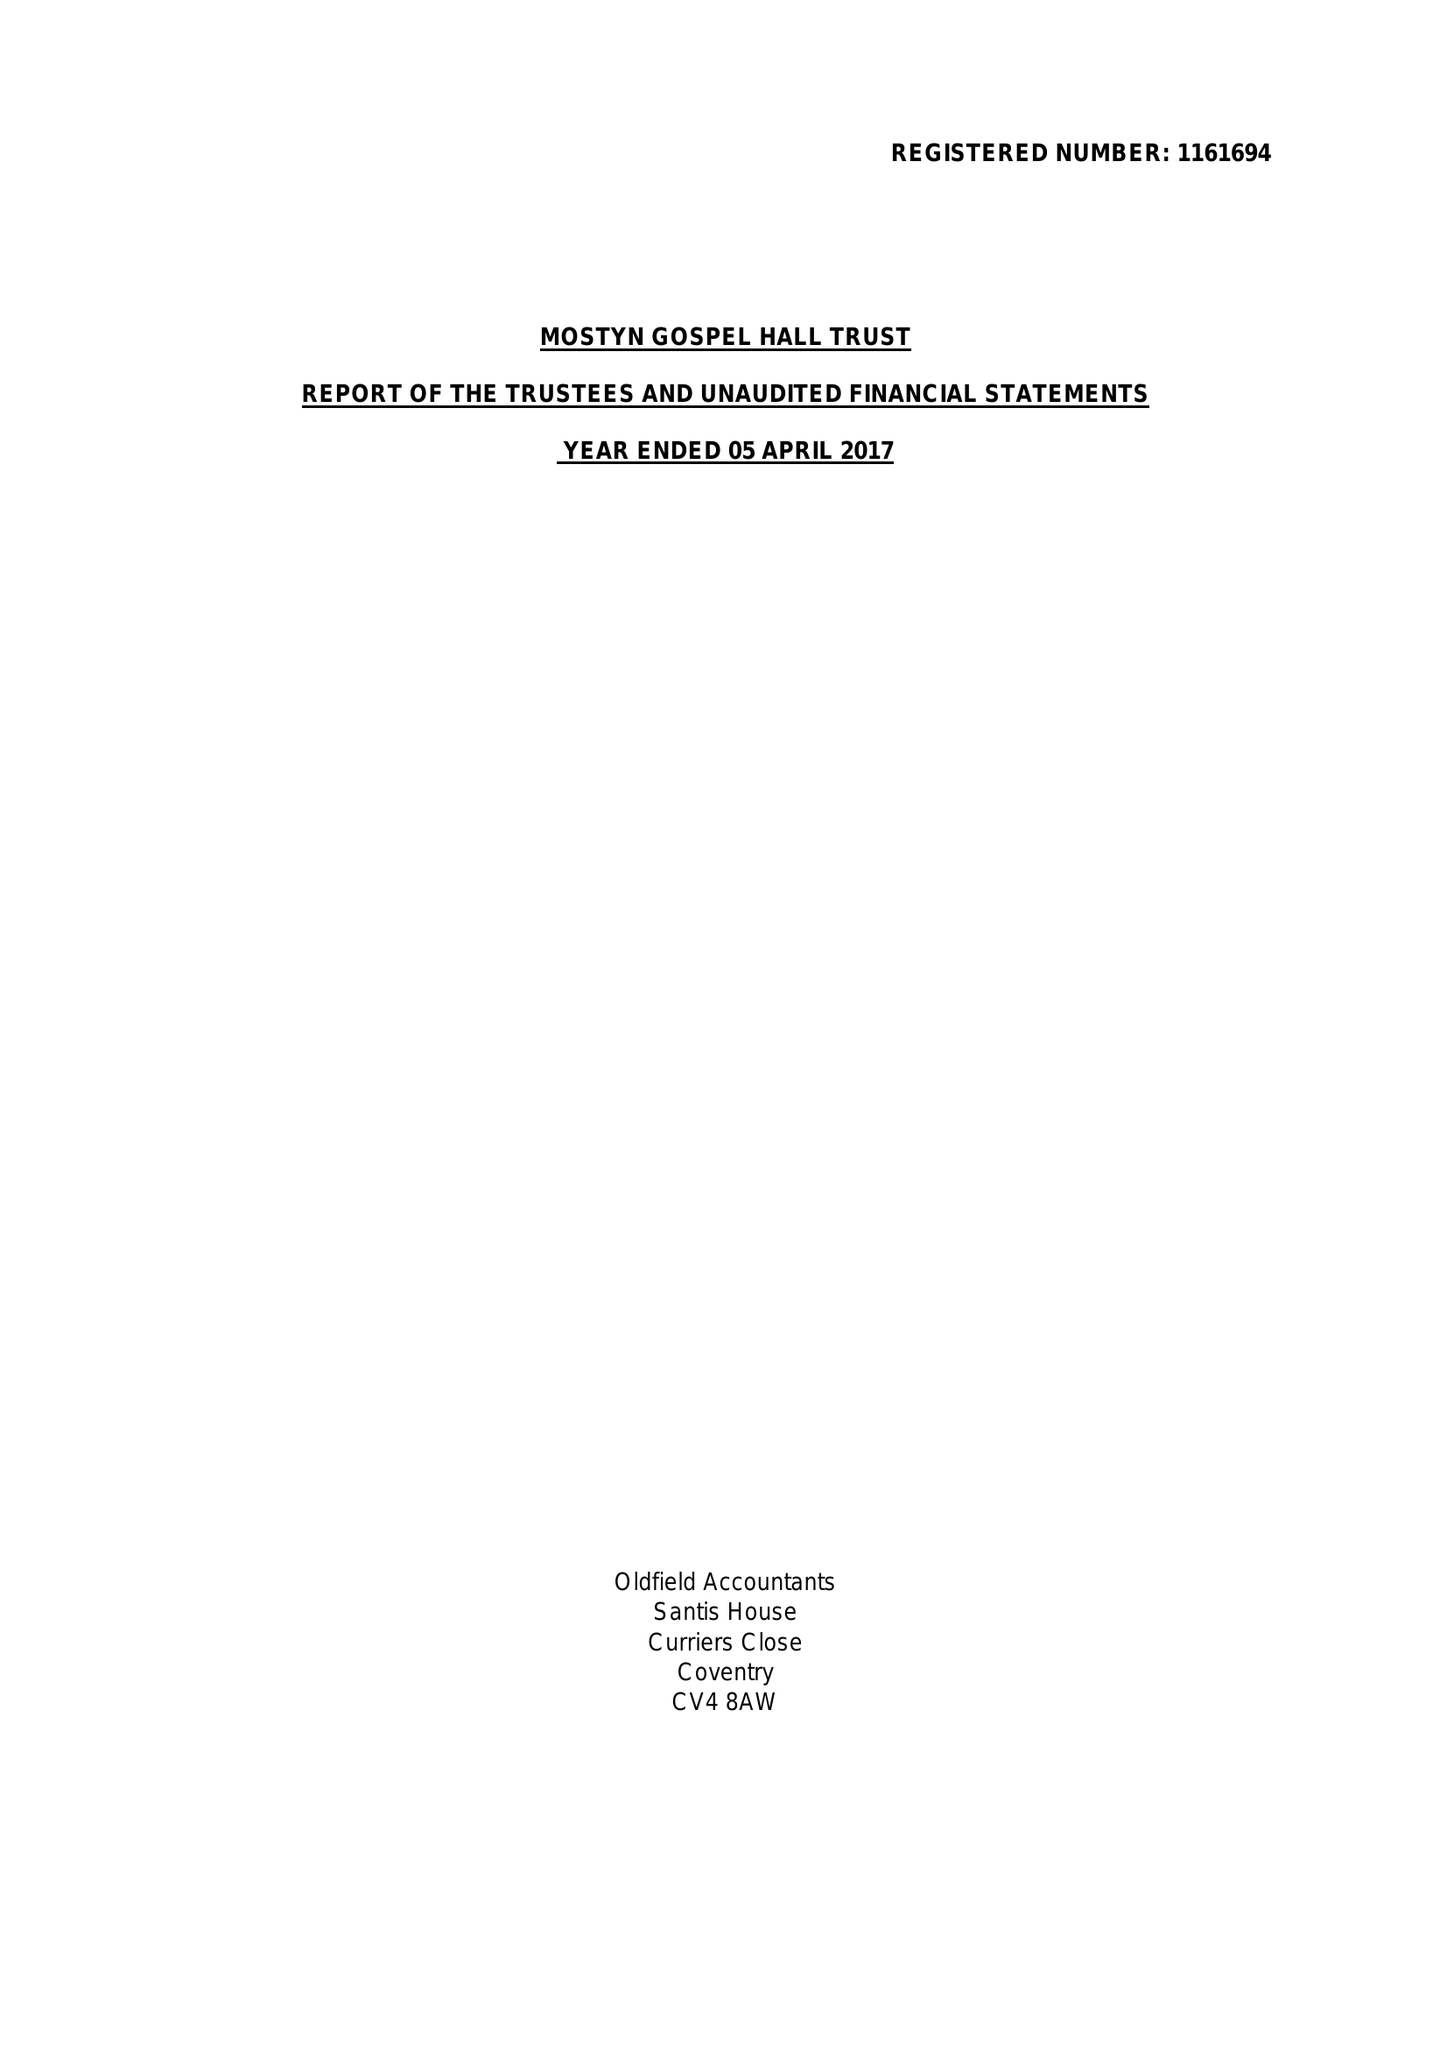What is the value for the address__postcode?
Answer the question using a single word or phrase. LE6 0JP 